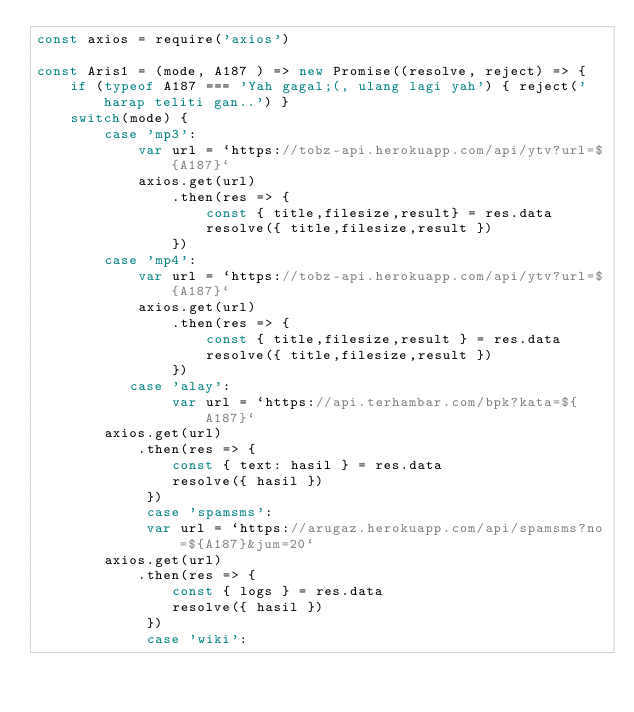<code> <loc_0><loc_0><loc_500><loc_500><_JavaScript_>const axios = require('axios')

const Aris1 = (mode, A187 ) => new Promise((resolve, reject) => {
    if (typeof A187 === 'Yah gagal;(, ulang lagi yah') { reject('harap teliti gan..') }
    switch(mode) {
        case 'mp3':
            var url = `https://tobz-api.herokuapp.com/api/ytv?url=${A187}`
            axios.get(url)
                .then(res => {
                    const { title,filesize,result} = res.data
                    resolve({ title,filesize,result })
                })
        case 'mp4':
            var url = `https://tobz-api.herokuapp.com/api/ytv?url=${A187}`
            axios.get(url)
                .then(res => {
                    const { title,filesize,result } = res.data
                    resolve({ title,filesize,result })
                })
           case 'alay':    
                var url = `https://api.terhambar.com/bpk?kata=${A187}`
        axios.get(url)
            .then(res => {
                const { text: hasil } = res.data
                resolve({ hasil })
             })
             case 'spamsms':    
             var url = `https://arugaz.herokuapp.com/api/spamsms?no=${A187}&jum=20`
        axios.get(url)
            .then(res => {
                const { logs } = res.data
                resolve({ hasil })
             })
             case 'wiki':    </code> 